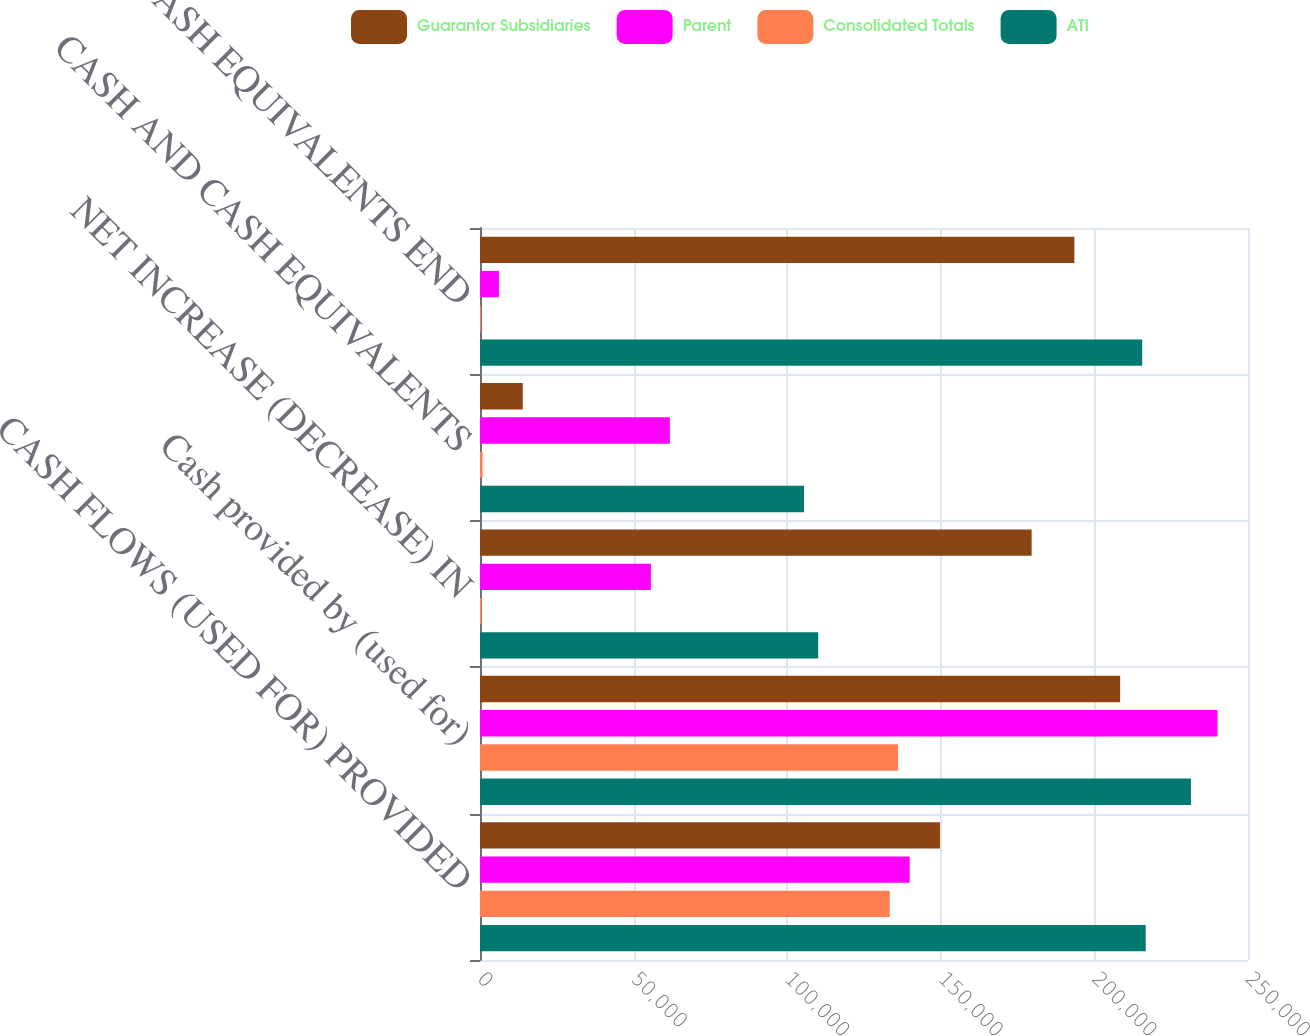Convert chart. <chart><loc_0><loc_0><loc_500><loc_500><stacked_bar_chart><ecel><fcel>CASH FLOWS (USED FOR) PROVIDED<fcel>Cash provided by (used for)<fcel>NET INCREASE (DECREASE) IN<fcel>CASH AND CASH EQUIVALENTS<fcel>CASH AND CASH EQUIVALENTS END<nl><fcel>Guarantor Subsidiaries<fcel>149729<fcel>208380<fcel>179566<fcel>13917<fcel>193483<nl><fcel>Parent<fcel>139876<fcel>240068<fcel>55635<fcel>61809<fcel>6174<nl><fcel>Consolidated Totals<fcel>133393<fcel>136100<fcel>529<fcel>836<fcel>307<nl><fcel>ATI<fcel>216700<fcel>231428<fcel>110092<fcel>105465<fcel>215557<nl></chart> 